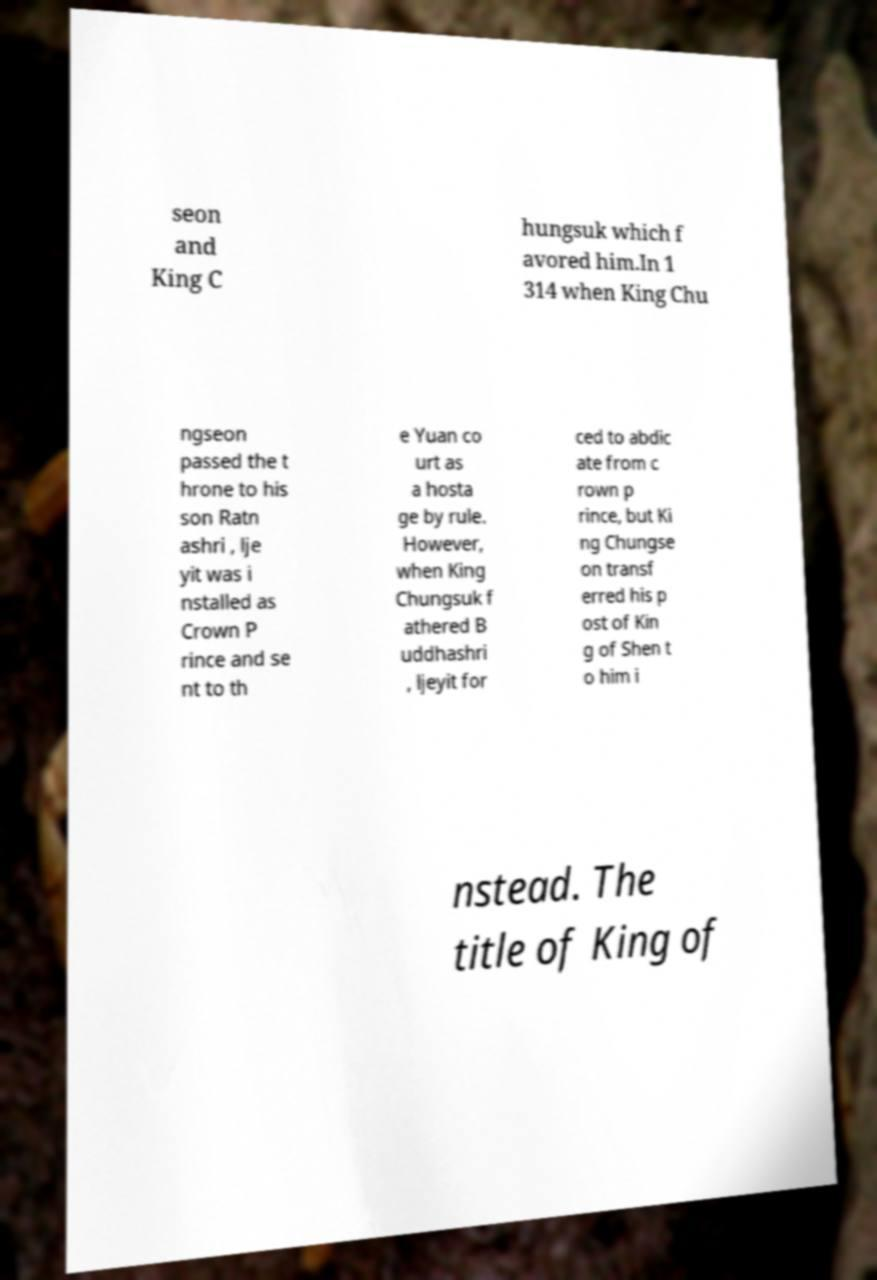There's text embedded in this image that I need extracted. Can you transcribe it verbatim? seon and King C hungsuk which f avored him.In 1 314 when King Chu ngseon passed the t hrone to his son Ratn ashri , lje yit was i nstalled as Crown P rince and se nt to th e Yuan co urt as a hosta ge by rule. However, when King Chungsuk f athered B uddhashri , ljeyit for ced to abdic ate from c rown p rince, but Ki ng Chungse on transf erred his p ost of Kin g of Shen t o him i nstead. The title of King of 